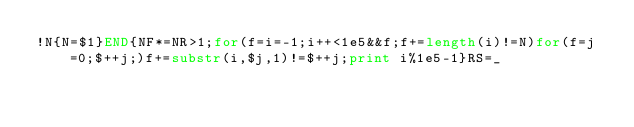<code> <loc_0><loc_0><loc_500><loc_500><_Awk_>!N{N=$1}END{NF*=NR>1;for(f=i=-1;i++<1e5&&f;f+=length(i)!=N)for(f=j=0;$++j;)f+=substr(i,$j,1)!=$++j;print i%1e5-1}RS=_</code> 